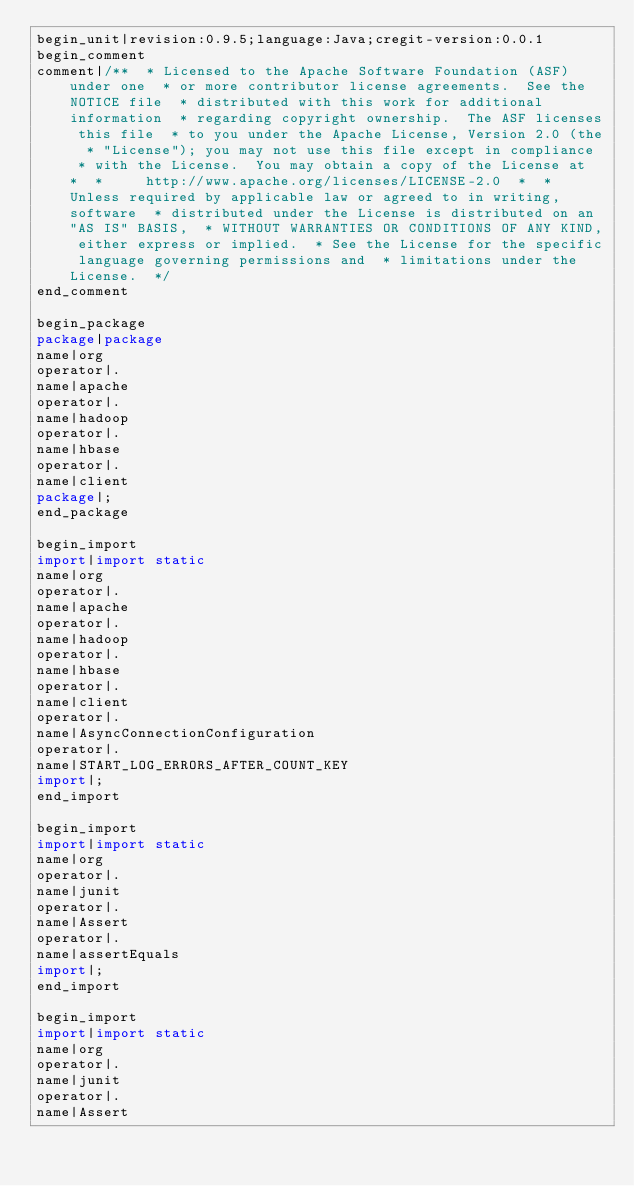Convert code to text. <code><loc_0><loc_0><loc_500><loc_500><_Java_>begin_unit|revision:0.9.5;language:Java;cregit-version:0.0.1
begin_comment
comment|/**  * Licensed to the Apache Software Foundation (ASF) under one  * or more contributor license agreements.  See the NOTICE file  * distributed with this work for additional information  * regarding copyright ownership.  The ASF licenses this file  * to you under the Apache License, Version 2.0 (the  * "License"); you may not use this file except in compliance  * with the License.  You may obtain a copy of the License at  *  *     http://www.apache.org/licenses/LICENSE-2.0  *  * Unless required by applicable law or agreed to in writing, software  * distributed under the License is distributed on an "AS IS" BASIS,  * WITHOUT WARRANTIES OR CONDITIONS OF ANY KIND, either express or implied.  * See the License for the specific language governing permissions and  * limitations under the License.  */
end_comment

begin_package
package|package
name|org
operator|.
name|apache
operator|.
name|hadoop
operator|.
name|hbase
operator|.
name|client
package|;
end_package

begin_import
import|import static
name|org
operator|.
name|apache
operator|.
name|hadoop
operator|.
name|hbase
operator|.
name|client
operator|.
name|AsyncConnectionConfiguration
operator|.
name|START_LOG_ERRORS_AFTER_COUNT_KEY
import|;
end_import

begin_import
import|import static
name|org
operator|.
name|junit
operator|.
name|Assert
operator|.
name|assertEquals
import|;
end_import

begin_import
import|import static
name|org
operator|.
name|junit
operator|.
name|Assert</code> 